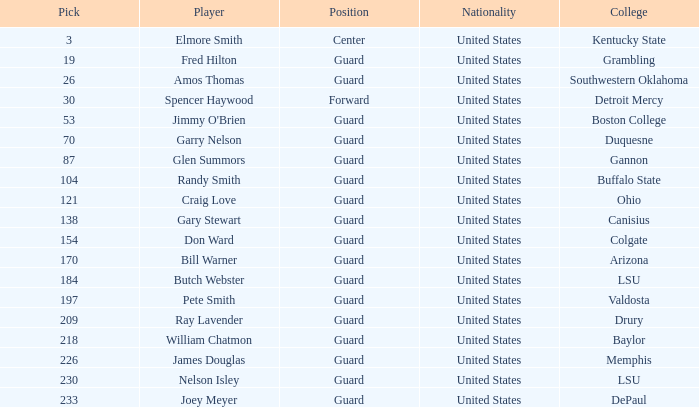WHAT IS THE NATIONALITY FOR SOUTHWESTERN OKLAHOMA? United States. Parse the table in full. {'header': ['Pick', 'Player', 'Position', 'Nationality', 'College'], 'rows': [['3', 'Elmore Smith', 'Center', 'United States', 'Kentucky State'], ['19', 'Fred Hilton', 'Guard', 'United States', 'Grambling'], ['26', 'Amos Thomas', 'Guard', 'United States', 'Southwestern Oklahoma'], ['30', 'Spencer Haywood', 'Forward', 'United States', 'Detroit Mercy'], ['53', "Jimmy O'Brien", 'Guard', 'United States', 'Boston College'], ['70', 'Garry Nelson', 'Guard', 'United States', 'Duquesne'], ['87', 'Glen Summors', 'Guard', 'United States', 'Gannon'], ['104', 'Randy Smith', 'Guard', 'United States', 'Buffalo State'], ['121', 'Craig Love', 'Guard', 'United States', 'Ohio'], ['138', 'Gary Stewart', 'Guard', 'United States', 'Canisius'], ['154', 'Don Ward', 'Guard', 'United States', 'Colgate'], ['170', 'Bill Warner', 'Guard', 'United States', 'Arizona'], ['184', 'Butch Webster', 'Guard', 'United States', 'LSU'], ['197', 'Pete Smith', 'Guard', 'United States', 'Valdosta'], ['209', 'Ray Lavender', 'Guard', 'United States', 'Drury'], ['218', 'William Chatmon', 'Guard', 'United States', 'Baylor'], ['226', 'James Douglas', 'Guard', 'United States', 'Memphis'], ['230', 'Nelson Isley', 'Guard', 'United States', 'LSU'], ['233', 'Joey Meyer', 'Guard', 'United States', 'DePaul']]} 